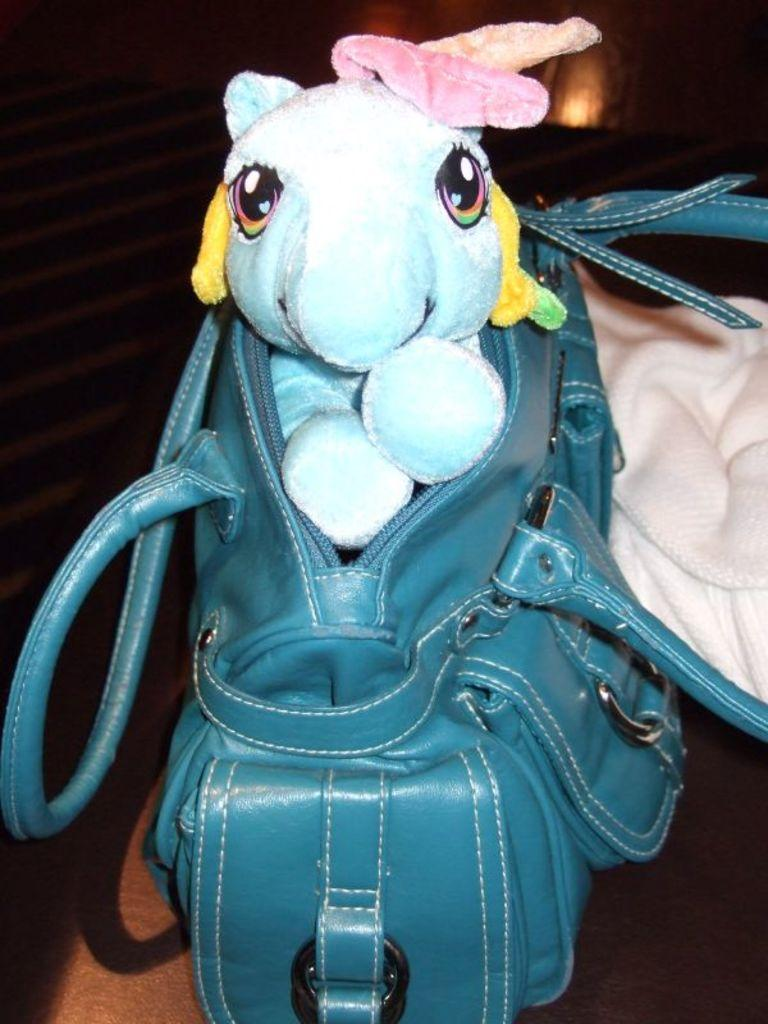What color is the bag that is visible in the image? There is a blue bag in the image. What is inside the blue bag? There is a white toy in the blue bag. What type of material is the cream-colored cloth in the image? The cream-colored cloth is present in the image. What can be seen in the background of the image? There are brown-colored stairs in the background of the image. What type of vest is the person wearing in the image? There is no person wearing a vest in the image. What is the weather like in the image, considering it's summer? The provided facts do not mention the weather or the season, so we cannot determine if it's summer or what the weather is like in the image. 